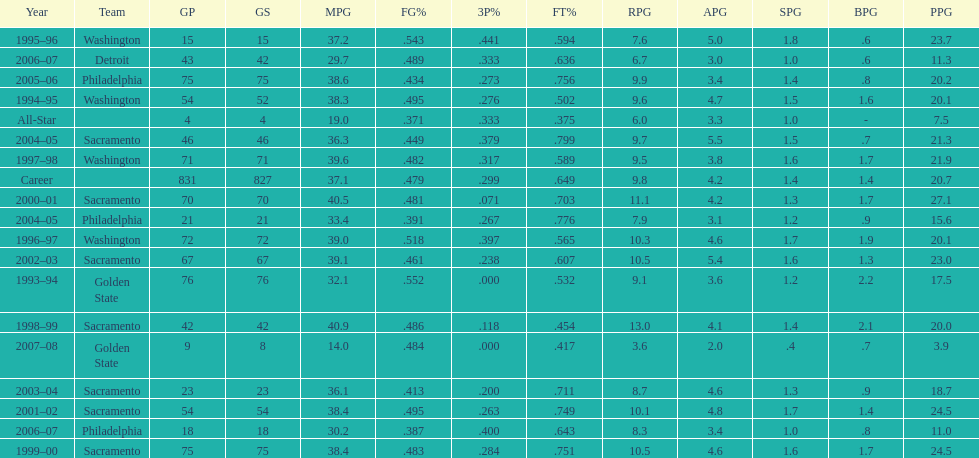How many seasons did webber average over 20 points per game (ppg)? 11. 